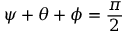Convert formula to latex. <formula><loc_0><loc_0><loc_500><loc_500>\psi + \theta + \phi = { \frac { \pi } { 2 } }</formula> 